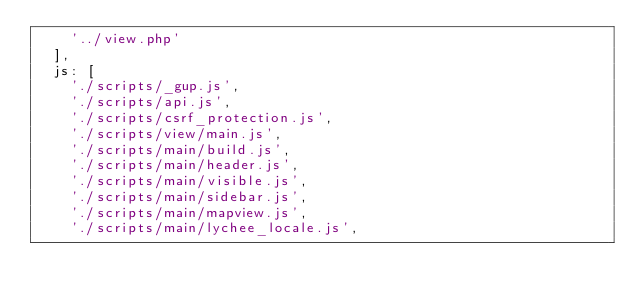Convert code to text. <code><loc_0><loc_0><loc_500><loc_500><_JavaScript_>		'../view.php'
	],
	js: [
		'./scripts/_gup.js',
		'./scripts/api.js',
		'./scripts/csrf_protection.js',
		'./scripts/view/main.js',
		'./scripts/main/build.js',
		'./scripts/main/header.js',
		'./scripts/main/visible.js',
		'./scripts/main/sidebar.js',
		'./scripts/main/mapview.js',
		'./scripts/main/lychee_locale.js',</code> 